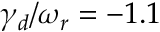<formula> <loc_0><loc_0><loc_500><loc_500>\gamma _ { d } / \omega _ { r } = - 1 . 1 \</formula> 